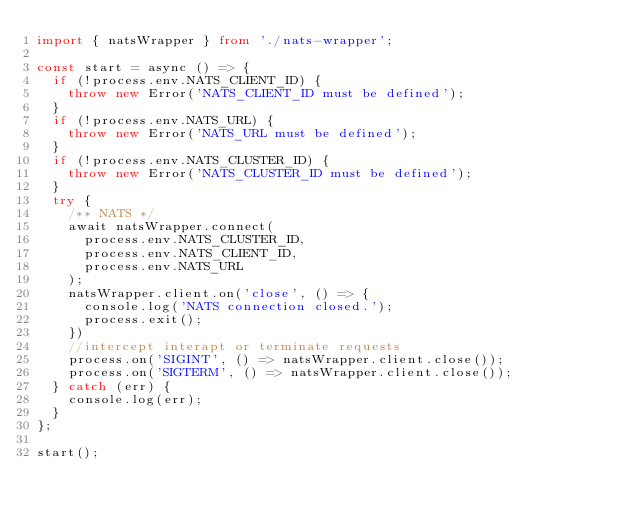<code> <loc_0><loc_0><loc_500><loc_500><_TypeScript_>import { natsWrapper } from './nats-wrapper';

const start = async () => {
  if (!process.env.NATS_CLIENT_ID) {
    throw new Error('NATS_CLIENT_ID must be defined');
  }
  if (!process.env.NATS_URL) {
    throw new Error('NATS_URL must be defined');
  }
  if (!process.env.NATS_CLUSTER_ID) {
    throw new Error('NATS_CLUSTER_ID must be defined');
  }
  try {
    /** NATS */
    await natsWrapper.connect(
      process.env.NATS_CLUSTER_ID,
      process.env.NATS_CLIENT_ID,
      process.env.NATS_URL
    );
    natsWrapper.client.on('close', () => {
      console.log('NATS connection closed.');
      process.exit();
    })
    //intercept interapt or terminate requests
    process.on('SIGINT', () => natsWrapper.client.close());
    process.on('SIGTERM', () => natsWrapper.client.close());
  } catch (err) {
    console.log(err);
  }
};

start();
</code> 